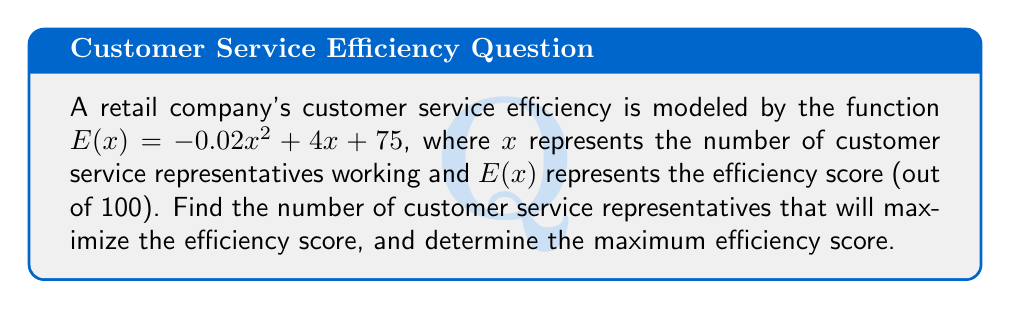Could you help me with this problem? To find the maximum efficiency point, we need to follow these steps:

1) The function $E(x) = -0.02x^2 + 4x + 75$ is a quadratic function, which forms a parabola when graphed. The maximum point of this parabola will represent the maximum efficiency.

2) To find the maximum point, we need to find the vertex of the parabola. For a quadratic function in the form $f(x) = ax^2 + bx + c$, the x-coordinate of the vertex is given by $x = -\frac{b}{2a}$.

3) In our function, $a = -0.02$, $b = 4$, and $c = 75$. Let's substitute these values:

   $x = -\frac{4}{2(-0.02)} = -\frac{4}{-0.04} = 100$

4) This means that the efficiency is maximized when there are 100 customer service representatives.

5) To find the maximum efficiency score, we need to calculate $E(100)$:

   $E(100) = -0.02(100)^2 + 4(100) + 75$
           $= -0.02(10000) + 400 + 75$
           $= -200 + 400 + 75$
           $= 275$

6) However, since the efficiency score is out of 100, we need to cap this at 100.

Therefore, the maximum efficiency score is 100, achieved when there are 100 customer service representatives working.
Answer: The maximum efficiency is achieved with 100 customer service representatives, resulting in an efficiency score of 100 (out of 100). 